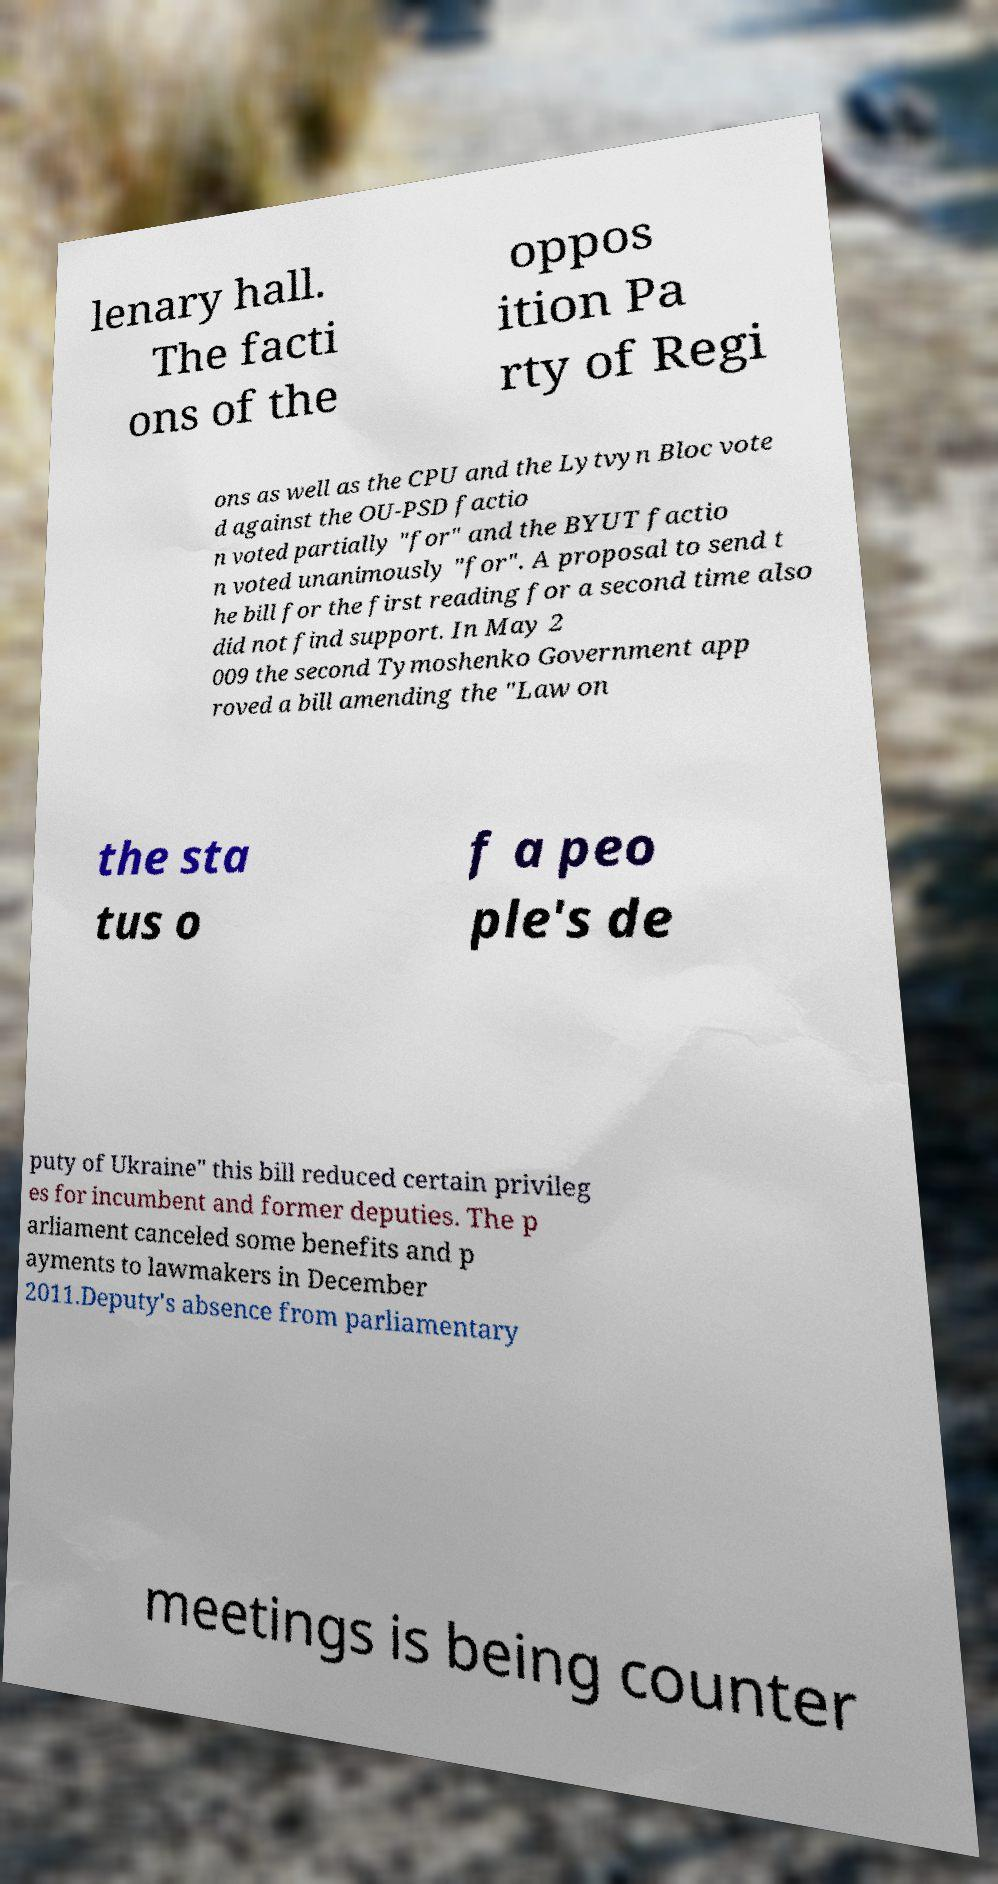There's text embedded in this image that I need extracted. Can you transcribe it verbatim? lenary hall. The facti ons of the oppos ition Pa rty of Regi ons as well as the CPU and the Lytvyn Bloc vote d against the OU-PSD factio n voted partially "for" and the BYUT factio n voted unanimously "for". A proposal to send t he bill for the first reading for a second time also did not find support. In May 2 009 the second Tymoshenko Government app roved a bill amending the "Law on the sta tus o f a peo ple's de puty of Ukraine" this bill reduced certain privileg es for incumbent and former deputies. The p arliament canceled some benefits and p ayments to lawmakers in December 2011.Deputy's absence from parliamentary meetings is being counter 